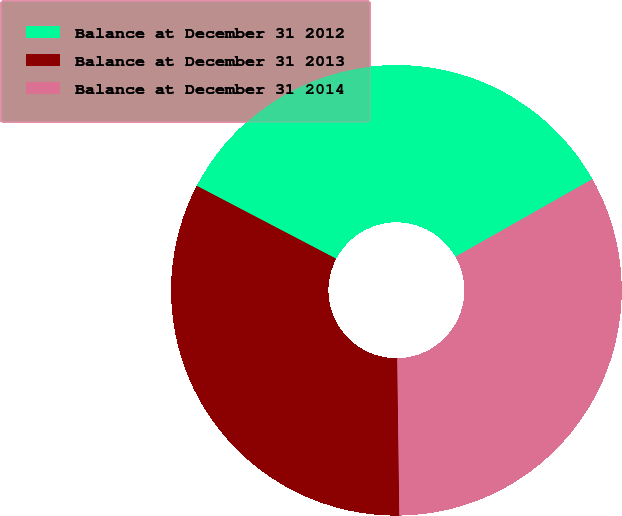Convert chart to OTSL. <chart><loc_0><loc_0><loc_500><loc_500><pie_chart><fcel>Balance at December 31 2012<fcel>Balance at December 31 2013<fcel>Balance at December 31 2014<nl><fcel>34.12%<fcel>32.88%<fcel>33.0%<nl></chart> 